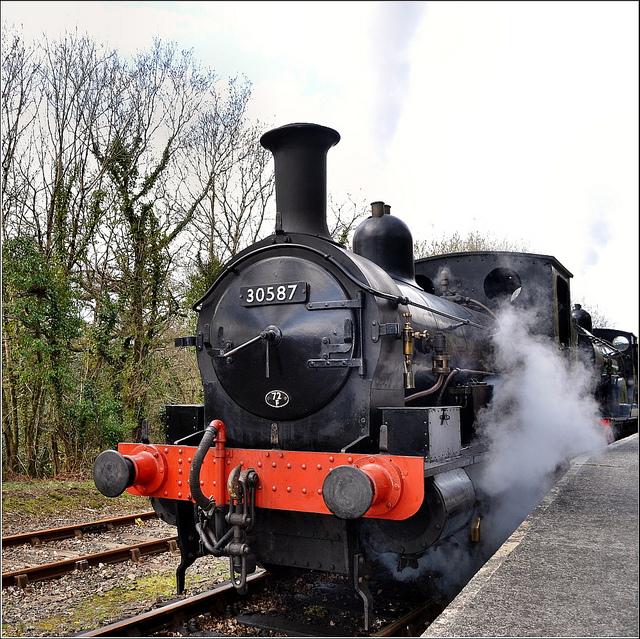Is the train functional?
Answer briefly. Yes. What is the number of the train?
Write a very short answer. 30587. What number is on the front of the train?
Be succinct. 30587. What color other than black is the train?
Quick response, please. Red. What does it say on the front of the train?
Be succinct. 30587. What powers this engine?
Short answer required. Steam. 